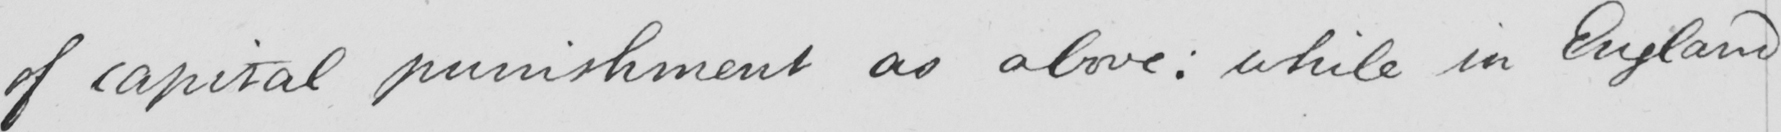What does this handwritten line say? of capital punishment as above :  while in England 